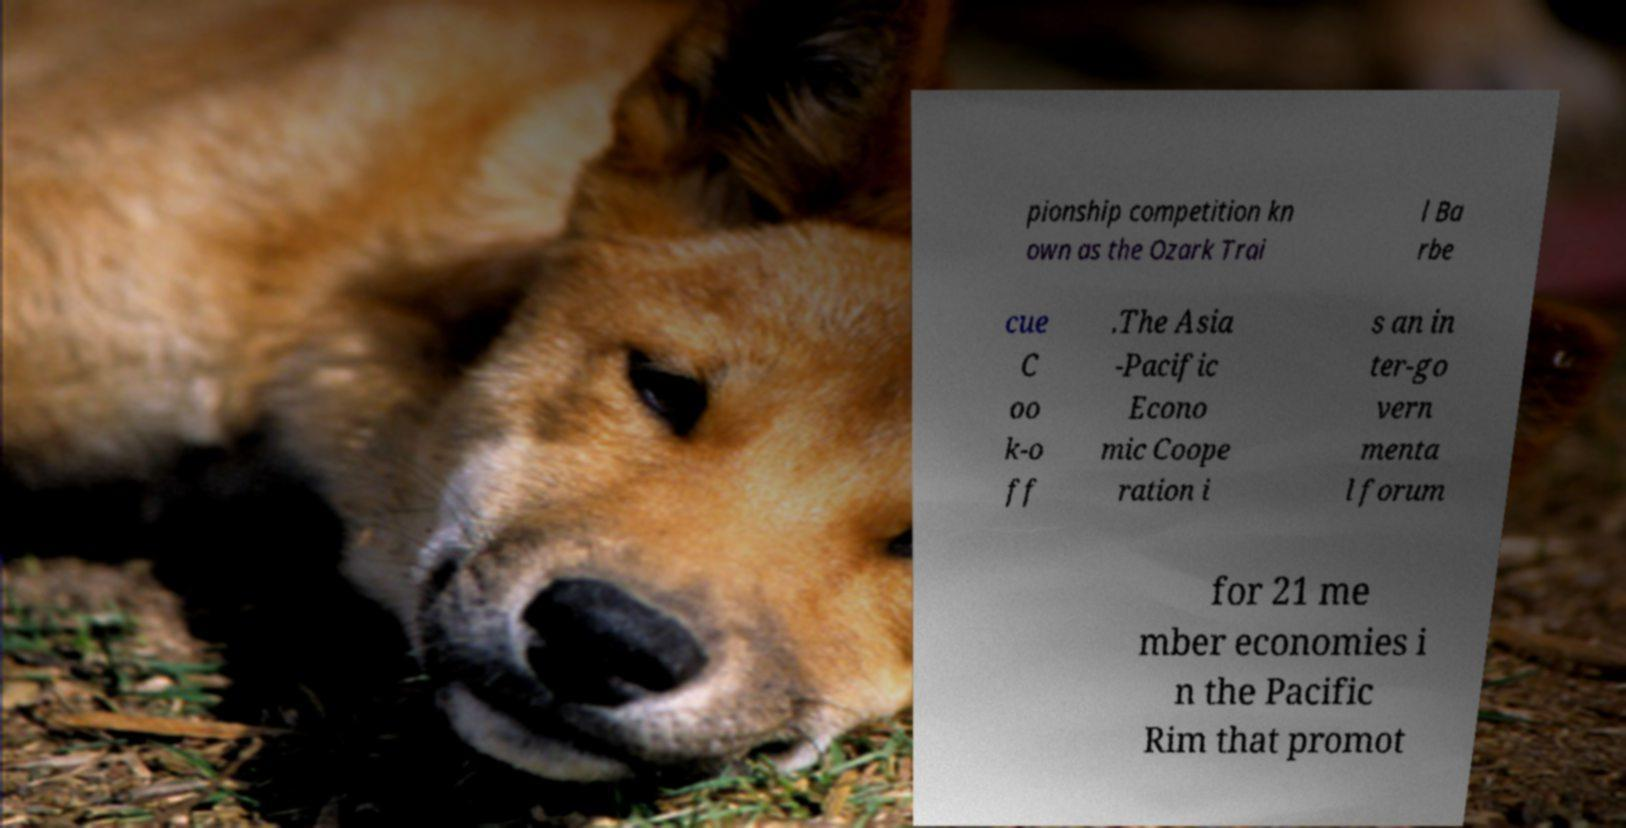Could you assist in decoding the text presented in this image and type it out clearly? pionship competition kn own as the Ozark Trai l Ba rbe cue C oo k-o ff .The Asia -Pacific Econo mic Coope ration i s an in ter-go vern menta l forum for 21 me mber economies i n the Pacific Rim that promot 